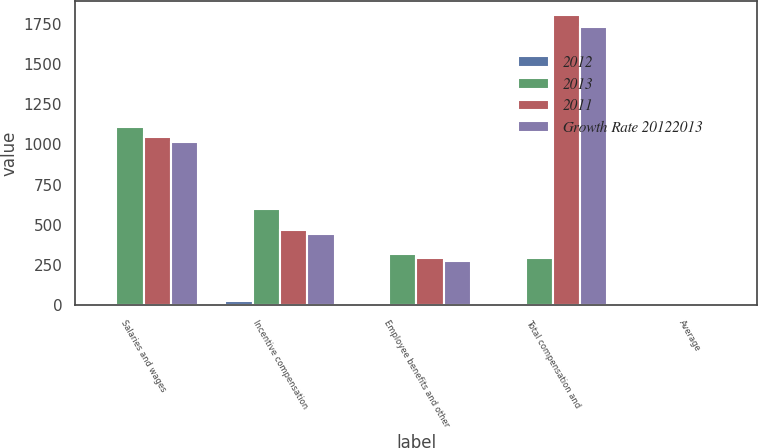<chart> <loc_0><loc_0><loc_500><loc_500><stacked_bar_chart><ecel><fcel>Salaries and wages<fcel>Incentive compensation<fcel>Employee benefits and other<fcel>Total compensation and<fcel>Average<nl><fcel>2012<fcel>6<fcel>29<fcel>8<fcel>12<fcel>1<nl><fcel>2013<fcel>1110<fcel>599<fcel>318<fcel>294<fcel>13.9<nl><fcel>2011<fcel>1043<fcel>466<fcel>294<fcel>1803<fcel>13.8<nl><fcel>Growth Rate 20122013<fcel>1012<fcel>444<fcel>276<fcel>1732<fcel>13.4<nl></chart> 